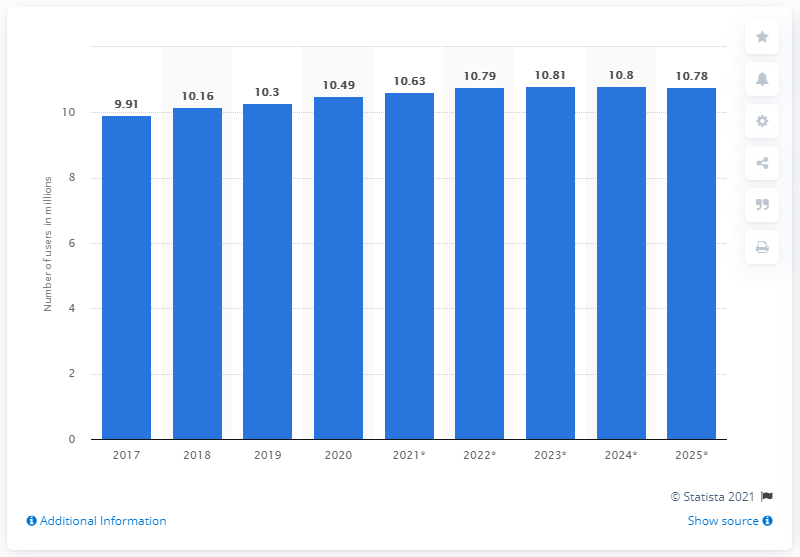Draw attention to some important aspects in this diagram. The projected number of Dutch users of Facebook by 2025 is 10.78 million. As of 2020, there were approximately 10.49 million Facebook users in the Netherlands. 